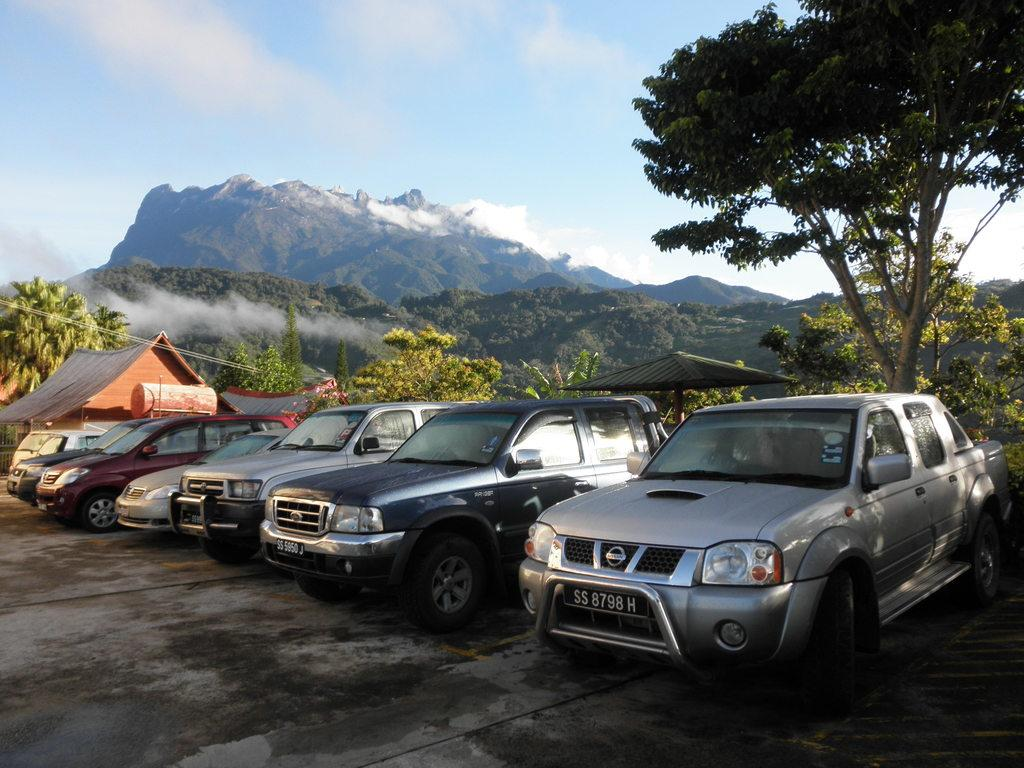What is located on the path in the image? There are vehicles parked on the path in the image. What is attached to the pole behind the vehicles? There is an umbrella attached to the pole behind the vehicles. What type of vegetation is visible behind the vehicles? Trees are visible behind the vehicles. What can be seen in the background of the image? Hills, fog, and the sky are visible in the background of the image. What type of achiever is visible in the image? There is no achiever present in the image; it features parked vehicles, a pole with an umbrella, trees, hills, fog, and the sky. What type of tin can be seen supporting the vehicles in the image? There is no tin present in the image. 